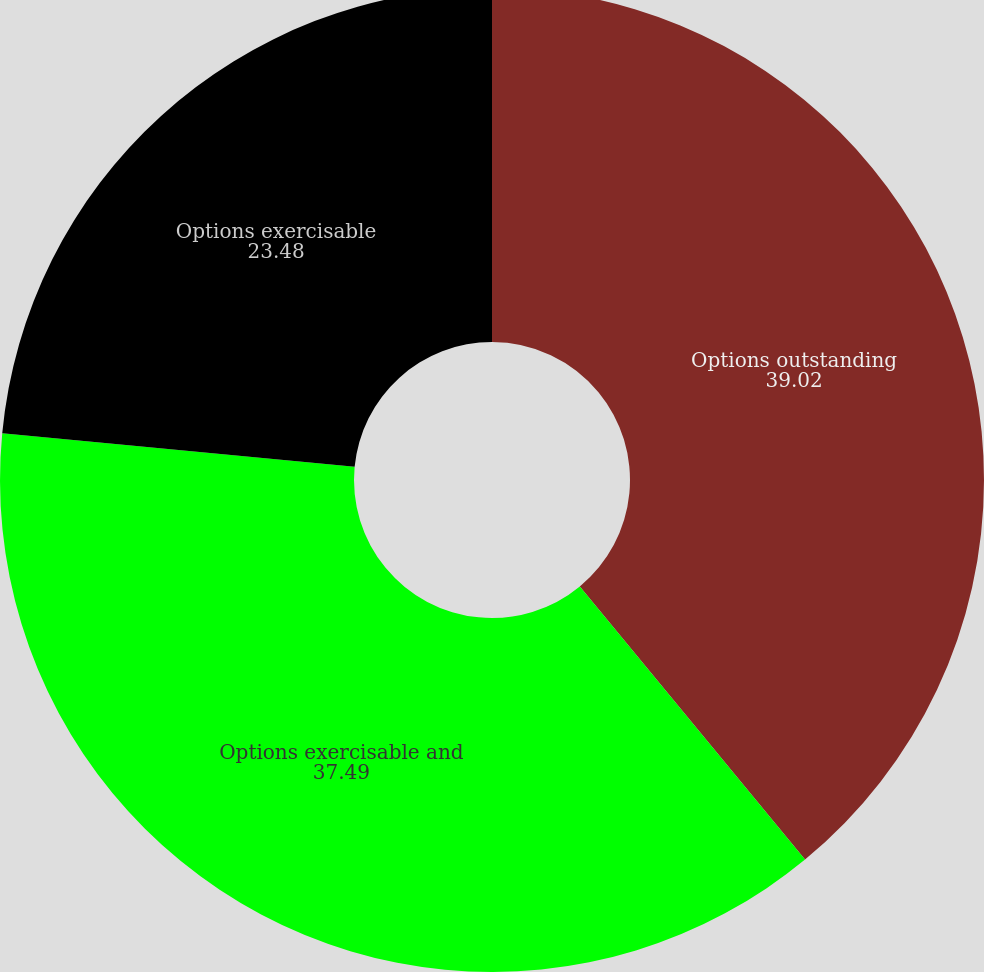Convert chart. <chart><loc_0><loc_0><loc_500><loc_500><pie_chart><fcel>Options outstanding<fcel>Options exercisable and<fcel>Options exercisable<nl><fcel>39.02%<fcel>37.49%<fcel>23.48%<nl></chart> 